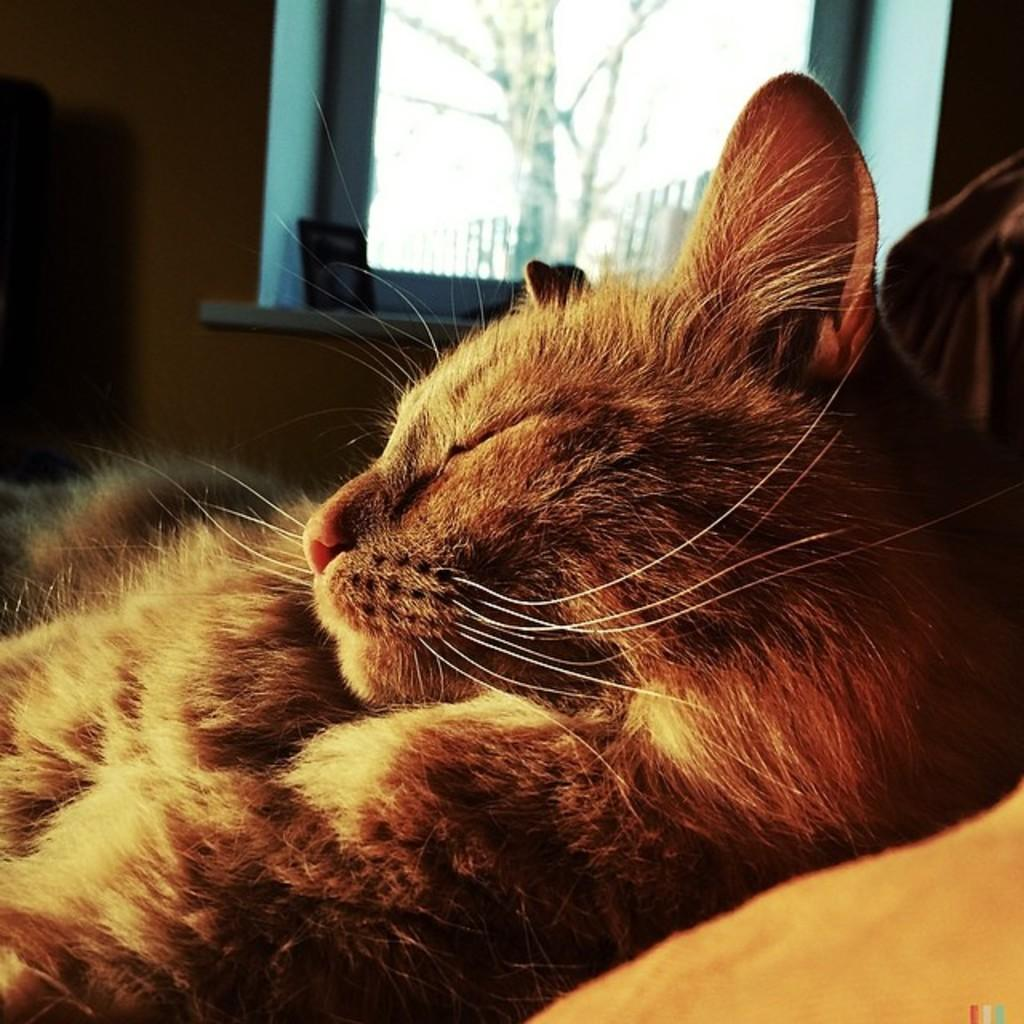What type of animal is in the room? The type of animal cannot be determined from the provided facts. What can be seen in the background of the room? There is a wall with a window, and objects are visible in the background. What is outside the window? There is a tree outside the window. What color is the crayon being used by the animal in the image? There is no crayon present in the image, and the animal's actions cannot be determined from the provided facts. 